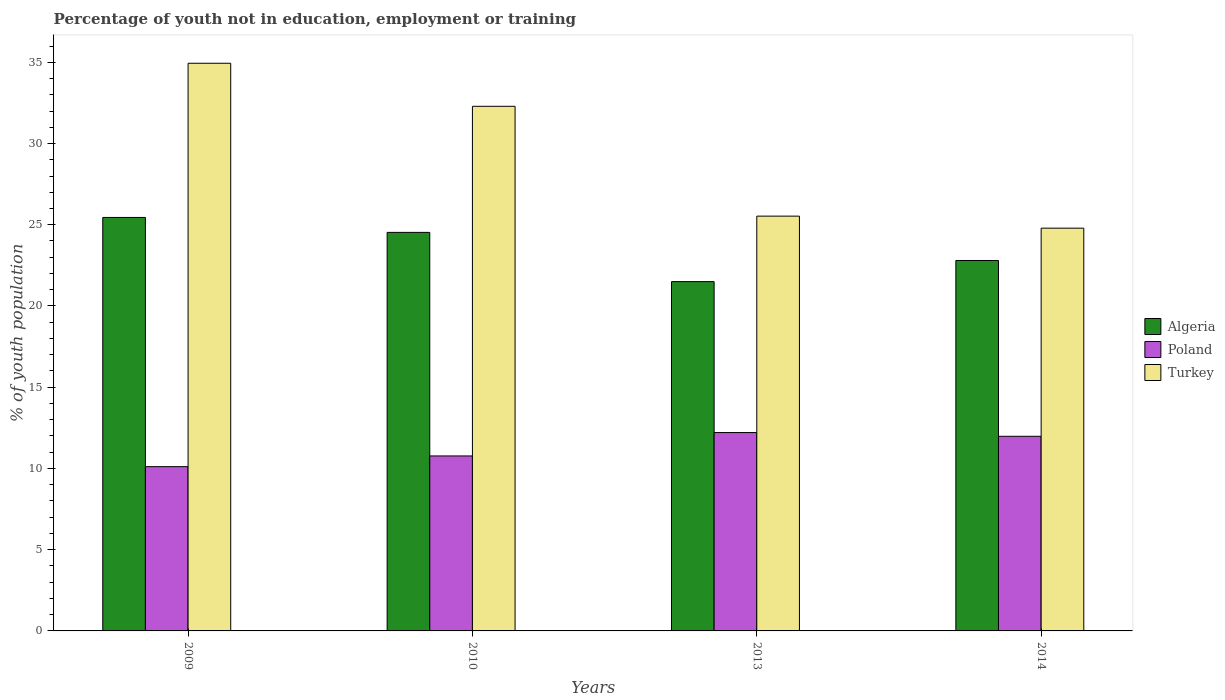How many different coloured bars are there?
Provide a short and direct response. 3. How many groups of bars are there?
Your answer should be very brief. 4. How many bars are there on the 4th tick from the left?
Your response must be concise. 3. In how many cases, is the number of bars for a given year not equal to the number of legend labels?
Your response must be concise. 0. What is the percentage of unemployed youth population in in Poland in 2014?
Offer a terse response. 11.98. Across all years, what is the maximum percentage of unemployed youth population in in Turkey?
Provide a short and direct response. 34.94. Across all years, what is the minimum percentage of unemployed youth population in in Poland?
Provide a succinct answer. 10.11. What is the total percentage of unemployed youth population in in Algeria in the graph?
Your answer should be very brief. 94.28. What is the difference between the percentage of unemployed youth population in in Poland in 2009 and that in 2010?
Your answer should be compact. -0.66. What is the difference between the percentage of unemployed youth population in in Turkey in 2014 and the percentage of unemployed youth population in in Algeria in 2009?
Offer a very short reply. -0.66. What is the average percentage of unemployed youth population in in Algeria per year?
Your answer should be compact. 23.57. In the year 2013, what is the difference between the percentage of unemployed youth population in in Turkey and percentage of unemployed youth population in in Poland?
Offer a terse response. 13.32. What is the ratio of the percentage of unemployed youth population in in Turkey in 2009 to that in 2014?
Your response must be concise. 1.41. What is the difference between the highest and the second highest percentage of unemployed youth population in in Turkey?
Provide a succinct answer. 2.65. What is the difference between the highest and the lowest percentage of unemployed youth population in in Turkey?
Keep it short and to the point. 10.15. Is the sum of the percentage of unemployed youth population in in Turkey in 2010 and 2014 greater than the maximum percentage of unemployed youth population in in Poland across all years?
Keep it short and to the point. Yes. What does the 3rd bar from the right in 2010 represents?
Your response must be concise. Algeria. Is it the case that in every year, the sum of the percentage of unemployed youth population in in Poland and percentage of unemployed youth population in in Turkey is greater than the percentage of unemployed youth population in in Algeria?
Make the answer very short. Yes. How many years are there in the graph?
Provide a succinct answer. 4. Does the graph contain any zero values?
Keep it short and to the point. No. What is the title of the graph?
Keep it short and to the point. Percentage of youth not in education, employment or training. Does "France" appear as one of the legend labels in the graph?
Offer a terse response. No. What is the label or title of the Y-axis?
Provide a succinct answer. % of youth population. What is the % of youth population of Algeria in 2009?
Make the answer very short. 25.45. What is the % of youth population in Poland in 2009?
Keep it short and to the point. 10.11. What is the % of youth population in Turkey in 2009?
Keep it short and to the point. 34.94. What is the % of youth population of Algeria in 2010?
Offer a very short reply. 24.53. What is the % of youth population in Poland in 2010?
Your answer should be compact. 10.77. What is the % of youth population in Turkey in 2010?
Provide a short and direct response. 32.29. What is the % of youth population of Algeria in 2013?
Keep it short and to the point. 21.5. What is the % of youth population of Poland in 2013?
Your response must be concise. 12.21. What is the % of youth population in Turkey in 2013?
Offer a very short reply. 25.53. What is the % of youth population in Algeria in 2014?
Make the answer very short. 22.8. What is the % of youth population in Poland in 2014?
Offer a terse response. 11.98. What is the % of youth population in Turkey in 2014?
Offer a terse response. 24.79. Across all years, what is the maximum % of youth population in Algeria?
Offer a very short reply. 25.45. Across all years, what is the maximum % of youth population in Poland?
Offer a terse response. 12.21. Across all years, what is the maximum % of youth population of Turkey?
Your answer should be very brief. 34.94. Across all years, what is the minimum % of youth population of Algeria?
Offer a very short reply. 21.5. Across all years, what is the minimum % of youth population of Poland?
Give a very brief answer. 10.11. Across all years, what is the minimum % of youth population in Turkey?
Give a very brief answer. 24.79. What is the total % of youth population of Algeria in the graph?
Make the answer very short. 94.28. What is the total % of youth population in Poland in the graph?
Offer a very short reply. 45.07. What is the total % of youth population in Turkey in the graph?
Offer a very short reply. 117.55. What is the difference between the % of youth population in Algeria in 2009 and that in 2010?
Offer a very short reply. 0.92. What is the difference between the % of youth population in Poland in 2009 and that in 2010?
Ensure brevity in your answer.  -0.66. What is the difference between the % of youth population in Turkey in 2009 and that in 2010?
Provide a short and direct response. 2.65. What is the difference between the % of youth population of Algeria in 2009 and that in 2013?
Your answer should be compact. 3.95. What is the difference between the % of youth population in Poland in 2009 and that in 2013?
Offer a very short reply. -2.1. What is the difference between the % of youth population of Turkey in 2009 and that in 2013?
Keep it short and to the point. 9.41. What is the difference between the % of youth population in Algeria in 2009 and that in 2014?
Your answer should be compact. 2.65. What is the difference between the % of youth population in Poland in 2009 and that in 2014?
Your response must be concise. -1.87. What is the difference between the % of youth population of Turkey in 2009 and that in 2014?
Ensure brevity in your answer.  10.15. What is the difference between the % of youth population of Algeria in 2010 and that in 2013?
Keep it short and to the point. 3.03. What is the difference between the % of youth population of Poland in 2010 and that in 2013?
Provide a succinct answer. -1.44. What is the difference between the % of youth population in Turkey in 2010 and that in 2013?
Your response must be concise. 6.76. What is the difference between the % of youth population of Algeria in 2010 and that in 2014?
Give a very brief answer. 1.73. What is the difference between the % of youth population of Poland in 2010 and that in 2014?
Offer a terse response. -1.21. What is the difference between the % of youth population of Algeria in 2013 and that in 2014?
Give a very brief answer. -1.3. What is the difference between the % of youth population in Poland in 2013 and that in 2014?
Offer a terse response. 0.23. What is the difference between the % of youth population in Turkey in 2013 and that in 2014?
Your answer should be very brief. 0.74. What is the difference between the % of youth population of Algeria in 2009 and the % of youth population of Poland in 2010?
Your answer should be very brief. 14.68. What is the difference between the % of youth population of Algeria in 2009 and the % of youth population of Turkey in 2010?
Provide a succinct answer. -6.84. What is the difference between the % of youth population in Poland in 2009 and the % of youth population in Turkey in 2010?
Make the answer very short. -22.18. What is the difference between the % of youth population of Algeria in 2009 and the % of youth population of Poland in 2013?
Offer a terse response. 13.24. What is the difference between the % of youth population of Algeria in 2009 and the % of youth population of Turkey in 2013?
Keep it short and to the point. -0.08. What is the difference between the % of youth population of Poland in 2009 and the % of youth population of Turkey in 2013?
Offer a terse response. -15.42. What is the difference between the % of youth population in Algeria in 2009 and the % of youth population in Poland in 2014?
Your answer should be compact. 13.47. What is the difference between the % of youth population of Algeria in 2009 and the % of youth population of Turkey in 2014?
Provide a short and direct response. 0.66. What is the difference between the % of youth population of Poland in 2009 and the % of youth population of Turkey in 2014?
Make the answer very short. -14.68. What is the difference between the % of youth population of Algeria in 2010 and the % of youth population of Poland in 2013?
Provide a short and direct response. 12.32. What is the difference between the % of youth population in Algeria in 2010 and the % of youth population in Turkey in 2013?
Make the answer very short. -1. What is the difference between the % of youth population of Poland in 2010 and the % of youth population of Turkey in 2013?
Offer a terse response. -14.76. What is the difference between the % of youth population in Algeria in 2010 and the % of youth population in Poland in 2014?
Offer a very short reply. 12.55. What is the difference between the % of youth population of Algeria in 2010 and the % of youth population of Turkey in 2014?
Give a very brief answer. -0.26. What is the difference between the % of youth population in Poland in 2010 and the % of youth population in Turkey in 2014?
Keep it short and to the point. -14.02. What is the difference between the % of youth population in Algeria in 2013 and the % of youth population in Poland in 2014?
Give a very brief answer. 9.52. What is the difference between the % of youth population of Algeria in 2013 and the % of youth population of Turkey in 2014?
Provide a succinct answer. -3.29. What is the difference between the % of youth population in Poland in 2013 and the % of youth population in Turkey in 2014?
Keep it short and to the point. -12.58. What is the average % of youth population in Algeria per year?
Your answer should be compact. 23.57. What is the average % of youth population in Poland per year?
Give a very brief answer. 11.27. What is the average % of youth population of Turkey per year?
Give a very brief answer. 29.39. In the year 2009, what is the difference between the % of youth population of Algeria and % of youth population of Poland?
Offer a very short reply. 15.34. In the year 2009, what is the difference between the % of youth population in Algeria and % of youth population in Turkey?
Offer a very short reply. -9.49. In the year 2009, what is the difference between the % of youth population in Poland and % of youth population in Turkey?
Offer a terse response. -24.83. In the year 2010, what is the difference between the % of youth population of Algeria and % of youth population of Poland?
Offer a terse response. 13.76. In the year 2010, what is the difference between the % of youth population of Algeria and % of youth population of Turkey?
Provide a succinct answer. -7.76. In the year 2010, what is the difference between the % of youth population of Poland and % of youth population of Turkey?
Give a very brief answer. -21.52. In the year 2013, what is the difference between the % of youth population in Algeria and % of youth population in Poland?
Give a very brief answer. 9.29. In the year 2013, what is the difference between the % of youth population of Algeria and % of youth population of Turkey?
Provide a short and direct response. -4.03. In the year 2013, what is the difference between the % of youth population of Poland and % of youth population of Turkey?
Offer a terse response. -13.32. In the year 2014, what is the difference between the % of youth population in Algeria and % of youth population in Poland?
Your answer should be very brief. 10.82. In the year 2014, what is the difference between the % of youth population of Algeria and % of youth population of Turkey?
Your answer should be very brief. -1.99. In the year 2014, what is the difference between the % of youth population in Poland and % of youth population in Turkey?
Your answer should be compact. -12.81. What is the ratio of the % of youth population of Algeria in 2009 to that in 2010?
Give a very brief answer. 1.04. What is the ratio of the % of youth population in Poland in 2009 to that in 2010?
Provide a succinct answer. 0.94. What is the ratio of the % of youth population of Turkey in 2009 to that in 2010?
Keep it short and to the point. 1.08. What is the ratio of the % of youth population of Algeria in 2009 to that in 2013?
Offer a terse response. 1.18. What is the ratio of the % of youth population in Poland in 2009 to that in 2013?
Offer a terse response. 0.83. What is the ratio of the % of youth population in Turkey in 2009 to that in 2013?
Your response must be concise. 1.37. What is the ratio of the % of youth population in Algeria in 2009 to that in 2014?
Your answer should be very brief. 1.12. What is the ratio of the % of youth population of Poland in 2009 to that in 2014?
Ensure brevity in your answer.  0.84. What is the ratio of the % of youth population in Turkey in 2009 to that in 2014?
Your answer should be compact. 1.41. What is the ratio of the % of youth population in Algeria in 2010 to that in 2013?
Offer a terse response. 1.14. What is the ratio of the % of youth population in Poland in 2010 to that in 2013?
Your answer should be compact. 0.88. What is the ratio of the % of youth population in Turkey in 2010 to that in 2013?
Make the answer very short. 1.26. What is the ratio of the % of youth population in Algeria in 2010 to that in 2014?
Offer a very short reply. 1.08. What is the ratio of the % of youth population in Poland in 2010 to that in 2014?
Keep it short and to the point. 0.9. What is the ratio of the % of youth population in Turkey in 2010 to that in 2014?
Your answer should be very brief. 1.3. What is the ratio of the % of youth population of Algeria in 2013 to that in 2014?
Provide a succinct answer. 0.94. What is the ratio of the % of youth population in Poland in 2013 to that in 2014?
Give a very brief answer. 1.02. What is the ratio of the % of youth population of Turkey in 2013 to that in 2014?
Keep it short and to the point. 1.03. What is the difference between the highest and the second highest % of youth population in Algeria?
Your response must be concise. 0.92. What is the difference between the highest and the second highest % of youth population of Poland?
Your response must be concise. 0.23. What is the difference between the highest and the second highest % of youth population in Turkey?
Your answer should be compact. 2.65. What is the difference between the highest and the lowest % of youth population of Algeria?
Provide a succinct answer. 3.95. What is the difference between the highest and the lowest % of youth population in Poland?
Provide a short and direct response. 2.1. What is the difference between the highest and the lowest % of youth population of Turkey?
Make the answer very short. 10.15. 